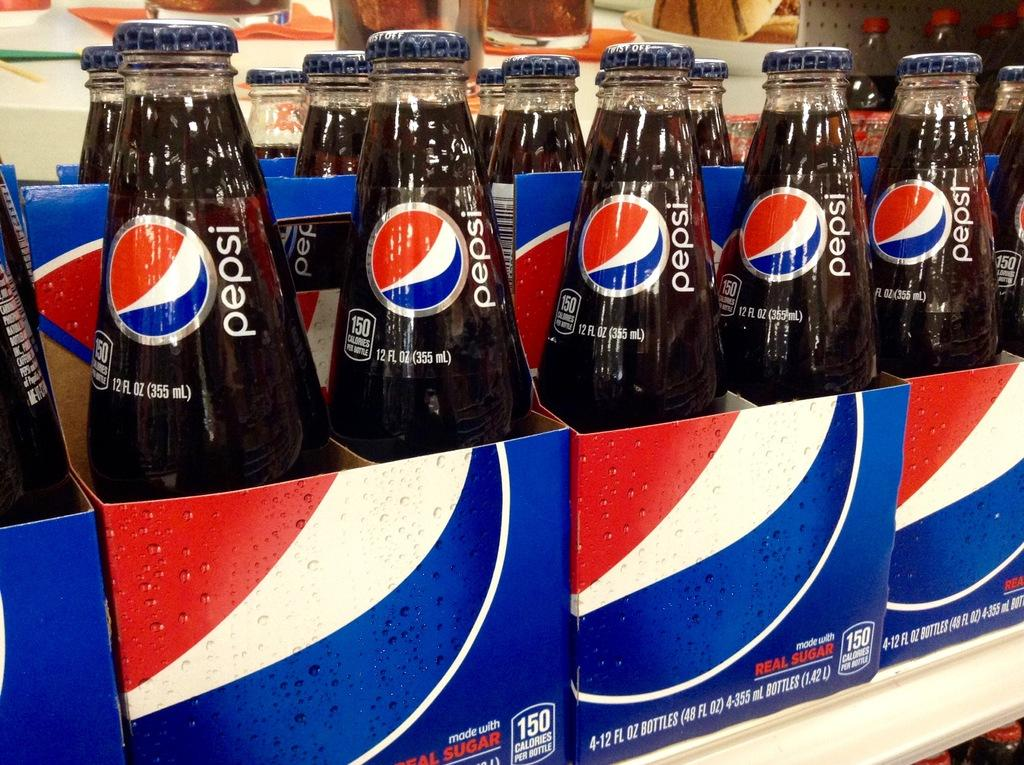<image>
Describe the image concisely. Glass bottles of Pepsi in a building being sold. 